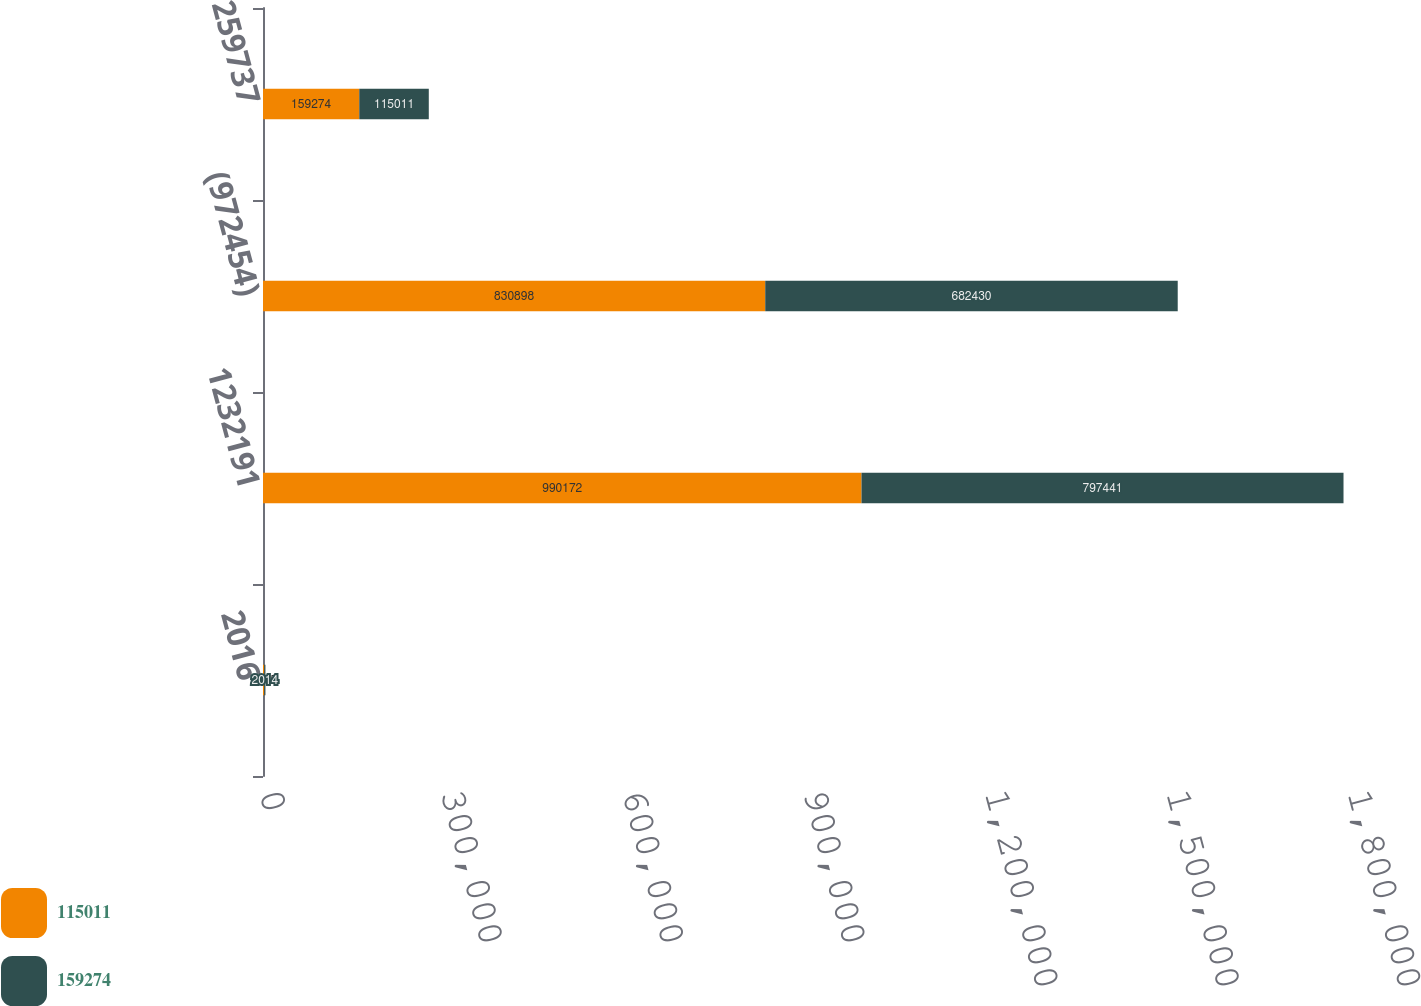<chart> <loc_0><loc_0><loc_500><loc_500><stacked_bar_chart><ecel><fcel>2016<fcel>1232191<fcel>(972454)<fcel>259737<nl><fcel>115011<fcel>2015<fcel>990172<fcel>830898<fcel>159274<nl><fcel>159274<fcel>2014<fcel>797441<fcel>682430<fcel>115011<nl></chart> 